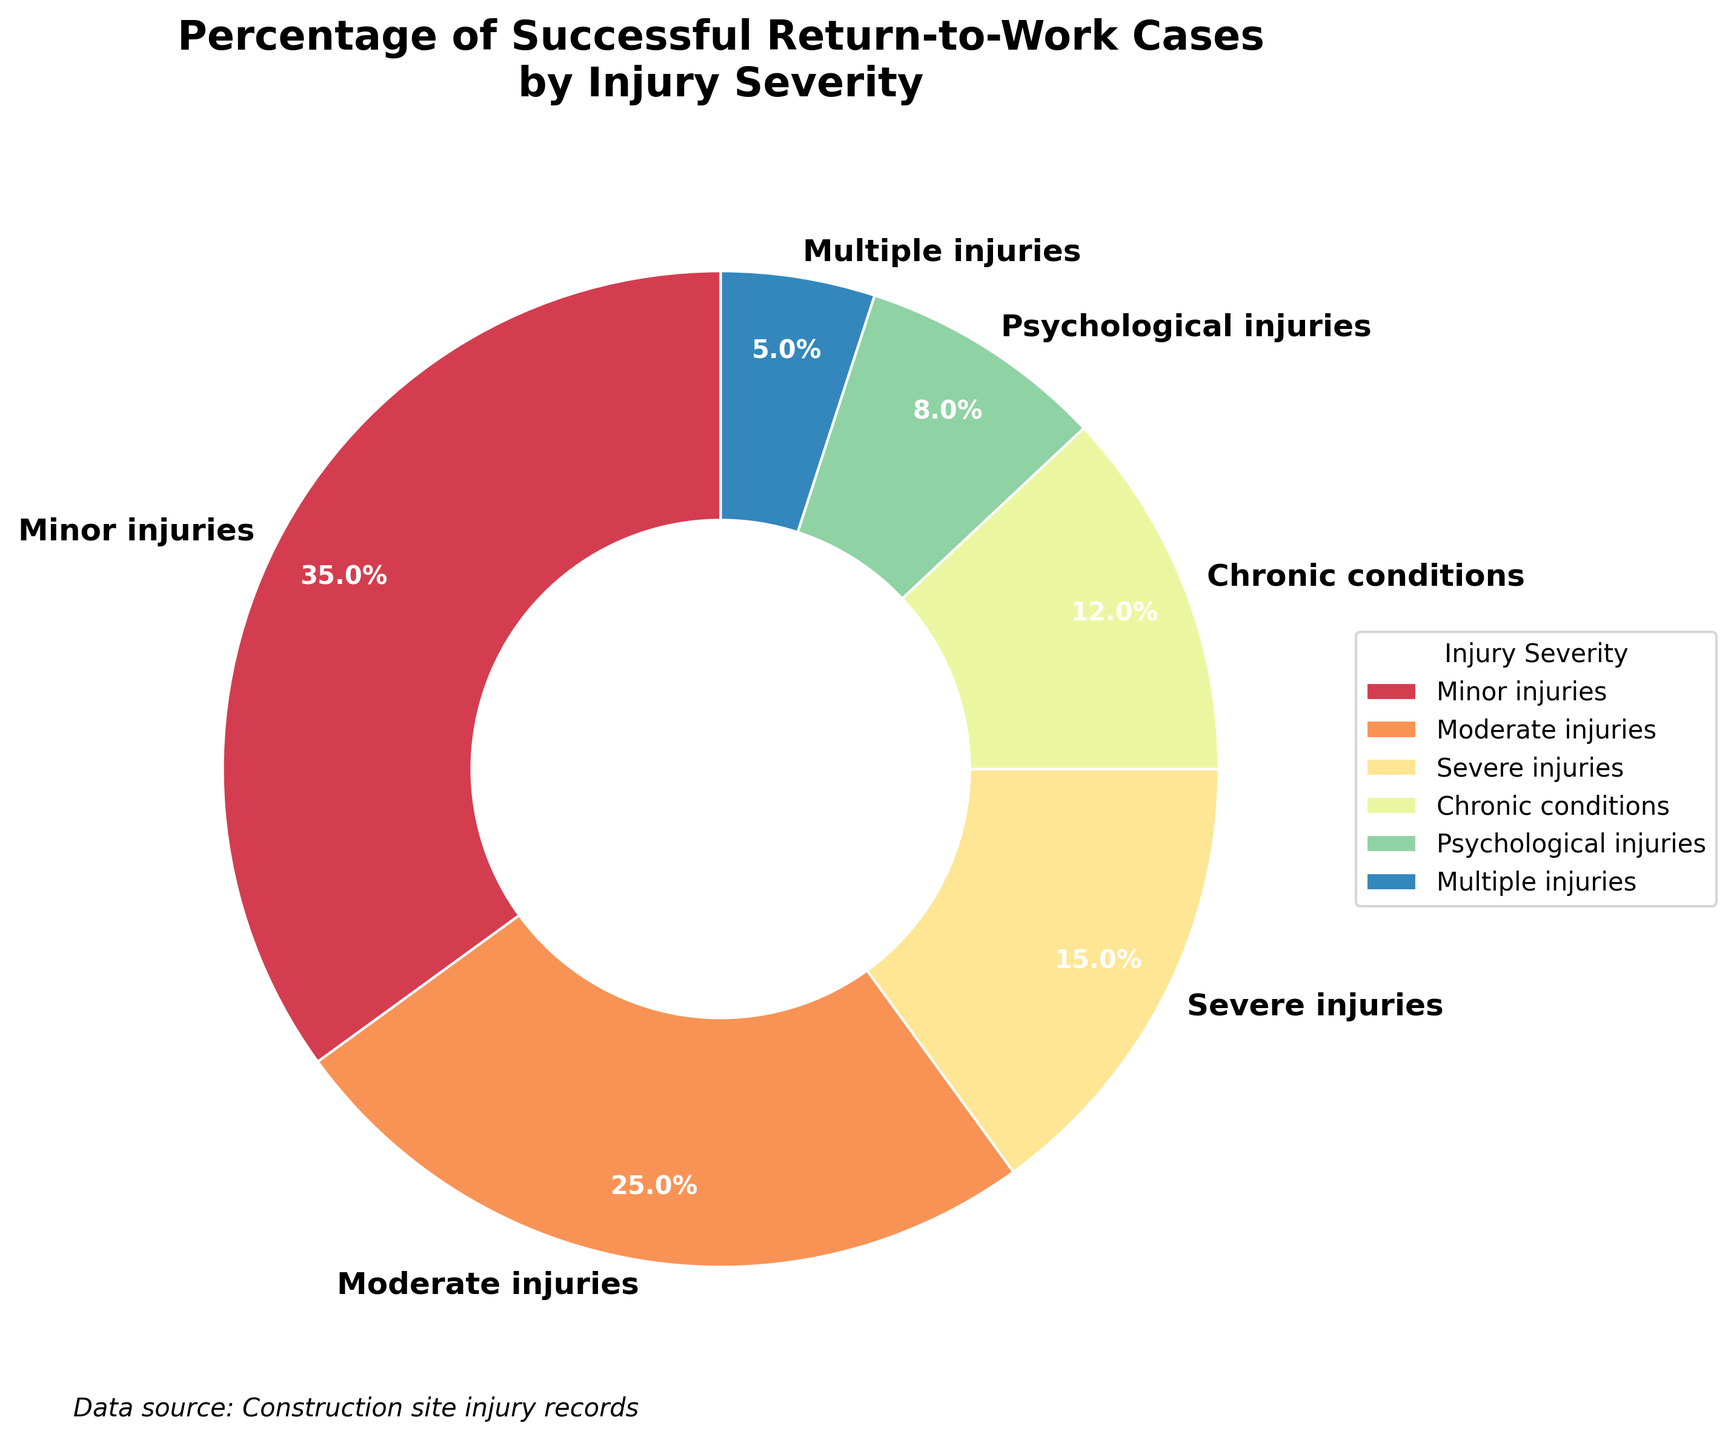What percentage of successful return-to-work cases are due to minor injuries? The pie chart indicates the percentage of successful return-to-work cases for each injury severity group. The slice labeled "Minor injuries" shows 35%.
Answer: 35% Which injury severity category has the highest percentage of successful return-to-work cases? By observing the pie chart, the largest slice corresponds to "Minor injuries" with 35%.
Answer: Minor injuries How do the percentages of successful return-to-work cases for moderate injuries and severe injuries compare? The pie chart shows that the percentage for moderate injuries is 25%, and for severe injuries is 15%. Therefore, moderate injuries have a higher percentage than severe injuries.
Answer: Moderate injuries have a higher percentage What is the total percentage of successful return-to-work cases for psychological injuries, chronic conditions, and multiple injuries combined? From the pie chart: Psychological injuries = 8%, Chronic conditions = 12%, and Multiple injuries = 5%. Adding these gives 8% + 12% + 5% = 25%.
Answer: 25% Which two injury severity categories together account for more than 50% of successful return-to-work cases? Looking at the chart, Minor injuries account for 35% and Moderate injuries account for 25%. Combined, they are 35% + 25% = 60%, which is more than 50%.
Answer: Minor and Moderate injuries Are chronic conditions more likely to result in a successful return-to-work than psychological injuries? The pie chart shows that chronic conditions account for 12% of successful return-to-work cases, while psychological injuries account for 8%. Therefore, chronic conditions are more likely.
Answer: Yes Which injury severity has the smallest percentage of successful return-to-work cases? Observing the smallest slice in the pie chart, Multiple injuries constitute 5%, which is the smallest percentage.
Answer: Multiple injuries What is the difference in percentage points between minor injuries and severe injuries for successful return-to-work cases? The pie chart shows minor injuries at 35% and severe injuries at 15%. The difference is 35% - 15% = 20%.
Answer: 20 percentage points What color appears to be associated with psychological injuries in the pie chart? Observing the visual attributes in the pie chart, psychological injuries are represented by a specific color. Since the chart uses a gradient, identifying the exact color might vary, but it appears as a distinct segment from the provided color map.
Answer: (insert specific observed color here) From the given pie chart, how much larger in percentage is the successful return-to-work rate for moderate injuries compared to that for multiple injuries? The pie chart shows 25% for moderate injuries and 5% for multiple injuries. The difference is 25% - 5% = 20%.
Answer: 20 percentage points 